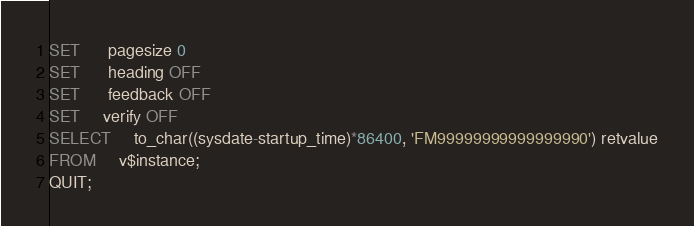<code> <loc_0><loc_0><loc_500><loc_500><_SQL_>SET      pagesize 0
SET      heading OFF
SET      feedback OFF
SET	 verify OFF
SELECT	 to_char((sysdate-startup_time)*86400, 'FM99999999999999990') retvalue
FROM	 v$instance;
QUIT;
</code> 